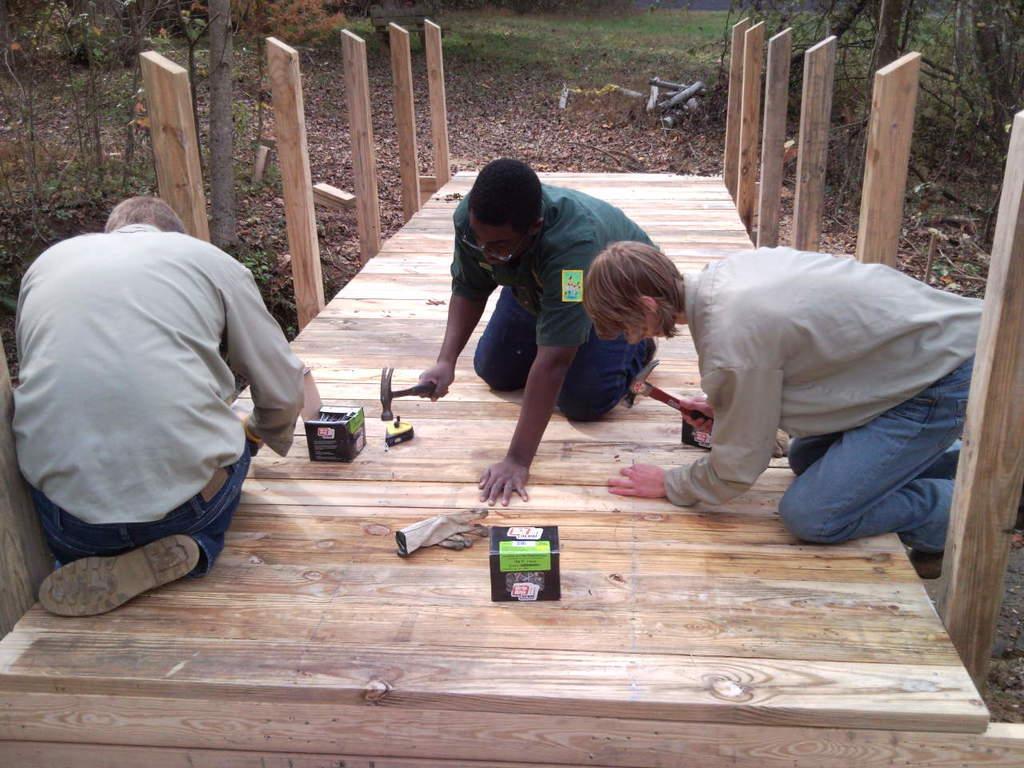Please provide a concise description of this image. In this image we can see three persons holding the hammers in their hands. We can also see two boxes and a glove on the wooden fence. On the backside we can see some plants, bark of a tree, wood, grass and the dried leaves. 